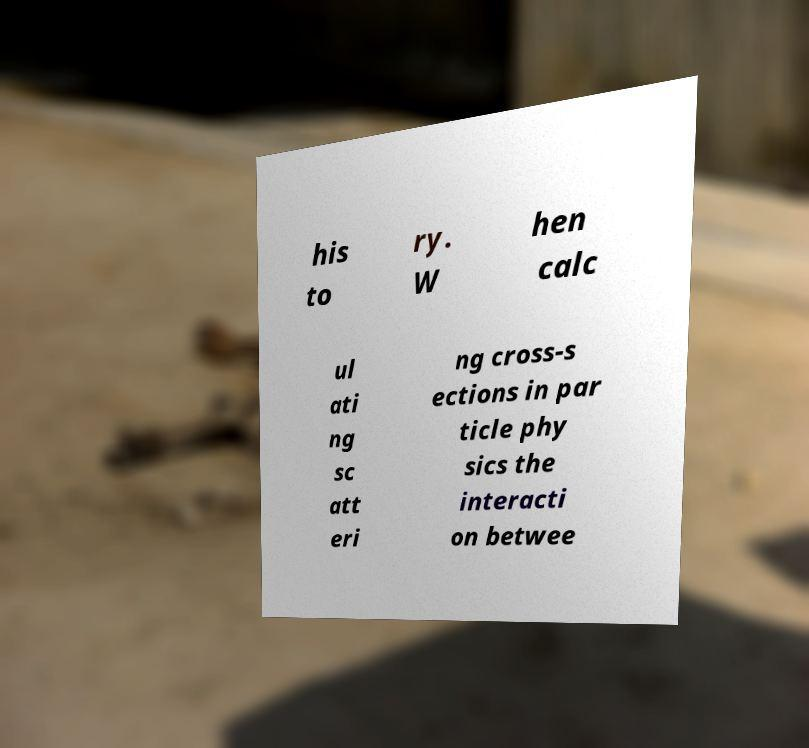Could you assist in decoding the text presented in this image and type it out clearly? his to ry. W hen calc ul ati ng sc att eri ng cross-s ections in par ticle phy sics the interacti on betwee 